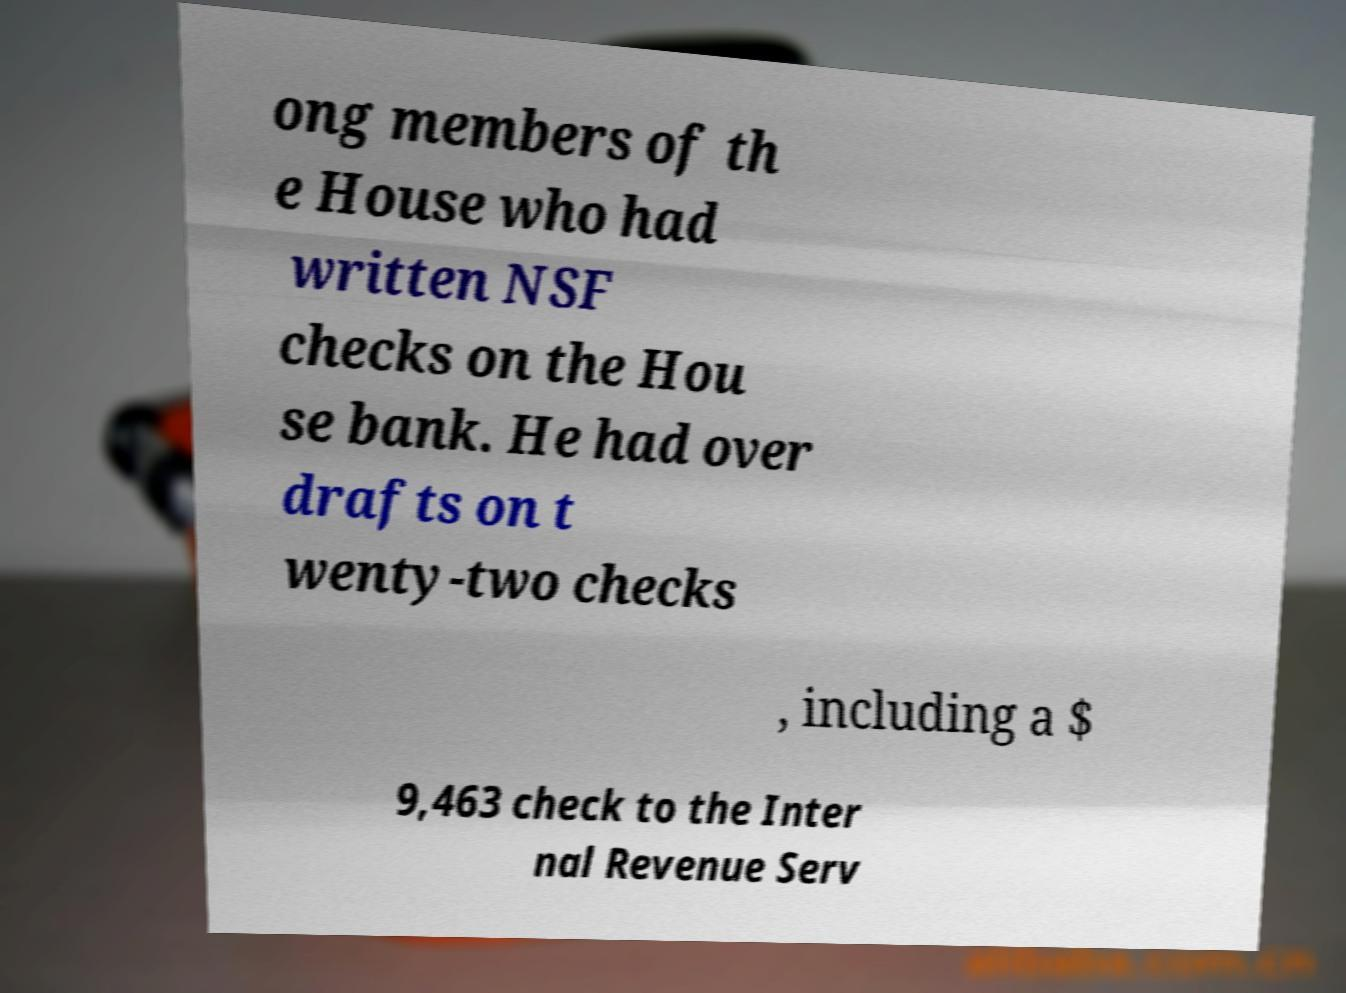Please identify and transcribe the text found in this image. ong members of th e House who had written NSF checks on the Hou se bank. He had over drafts on t wenty-two checks , including a $ 9,463 check to the Inter nal Revenue Serv 